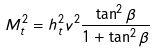<formula> <loc_0><loc_0><loc_500><loc_500>M _ { t } ^ { 2 } = h _ { t } ^ { 2 } v ^ { 2 } \frac { \tan ^ { 2 } { \beta } } { 1 + \tan ^ { 2 } { \beta } }</formula> 